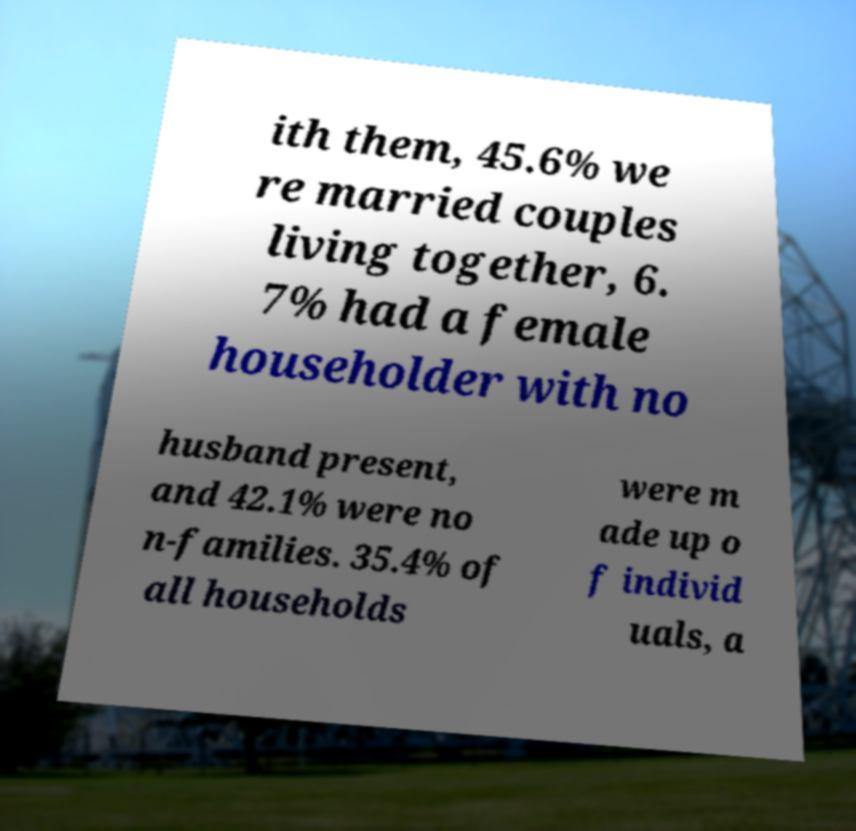For documentation purposes, I need the text within this image transcribed. Could you provide that? ith them, 45.6% we re married couples living together, 6. 7% had a female householder with no husband present, and 42.1% were no n-families. 35.4% of all households were m ade up o f individ uals, a 